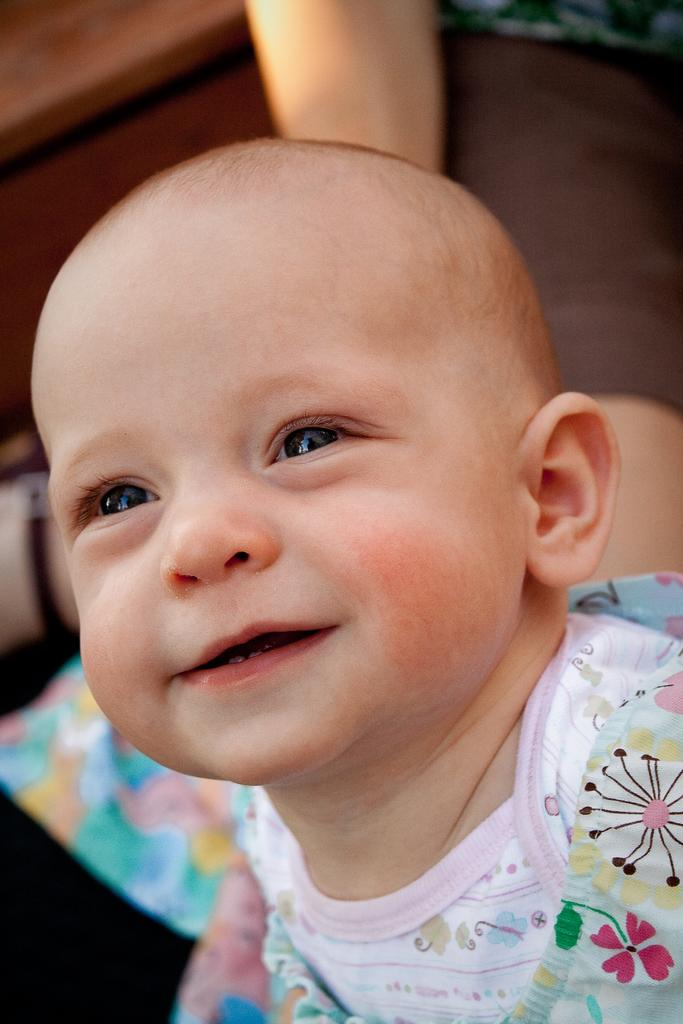What is the main subject of the picture? The main subject of the picture is a kid. What is the kid doing in the image? The kid is smiling. Can you describe the background of the image? The background of the image is not clear. What is the purpose of the elbow in the image? There is no mention of an elbow in the image, so it cannot be determined what its purpose might be. 